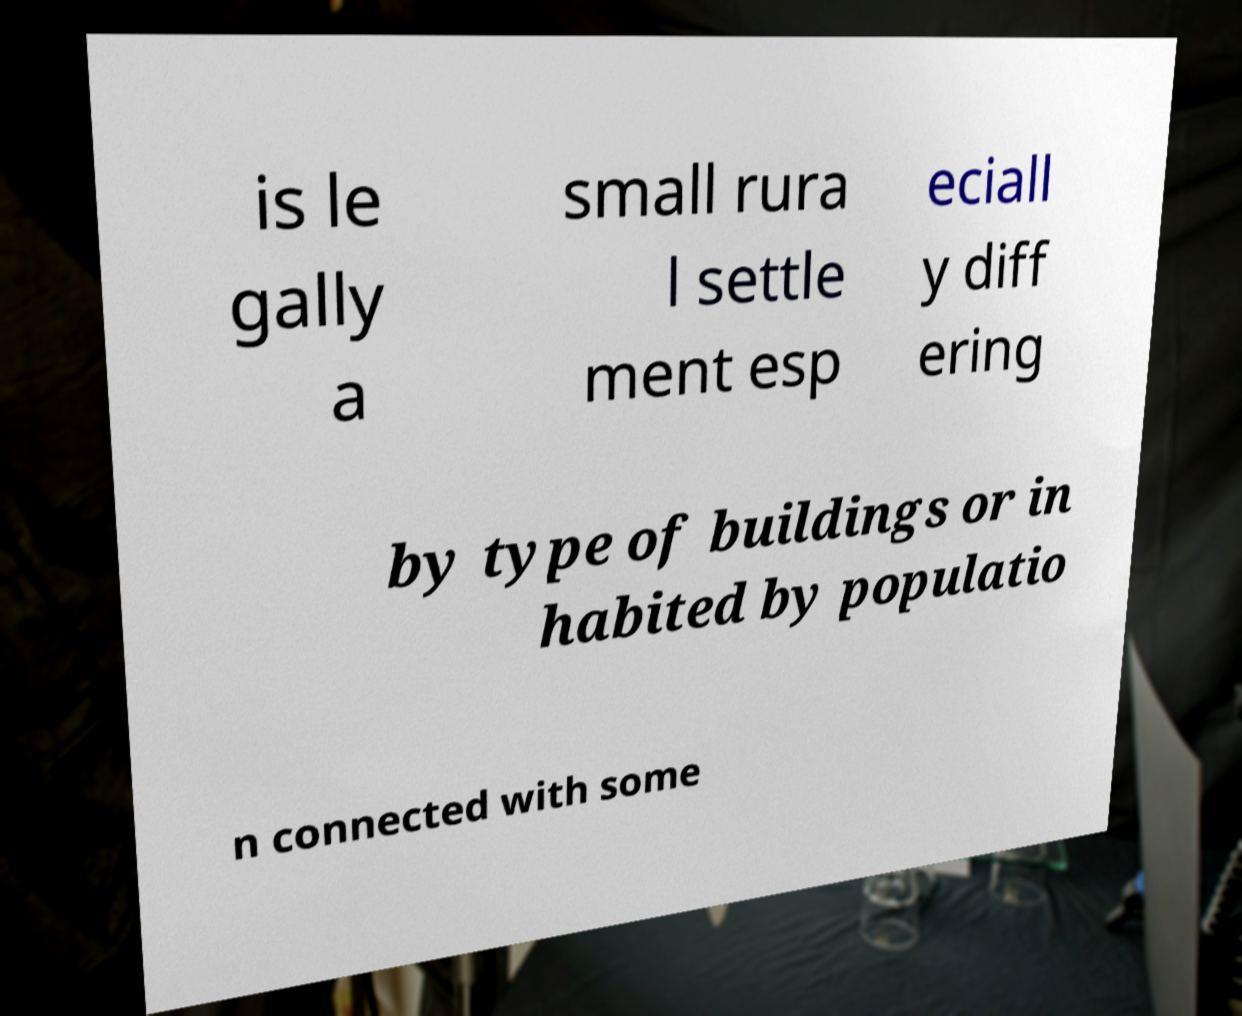Can you read and provide the text displayed in the image?This photo seems to have some interesting text. Can you extract and type it out for me? is le gally a small rura l settle ment esp eciall y diff ering by type of buildings or in habited by populatio n connected with some 